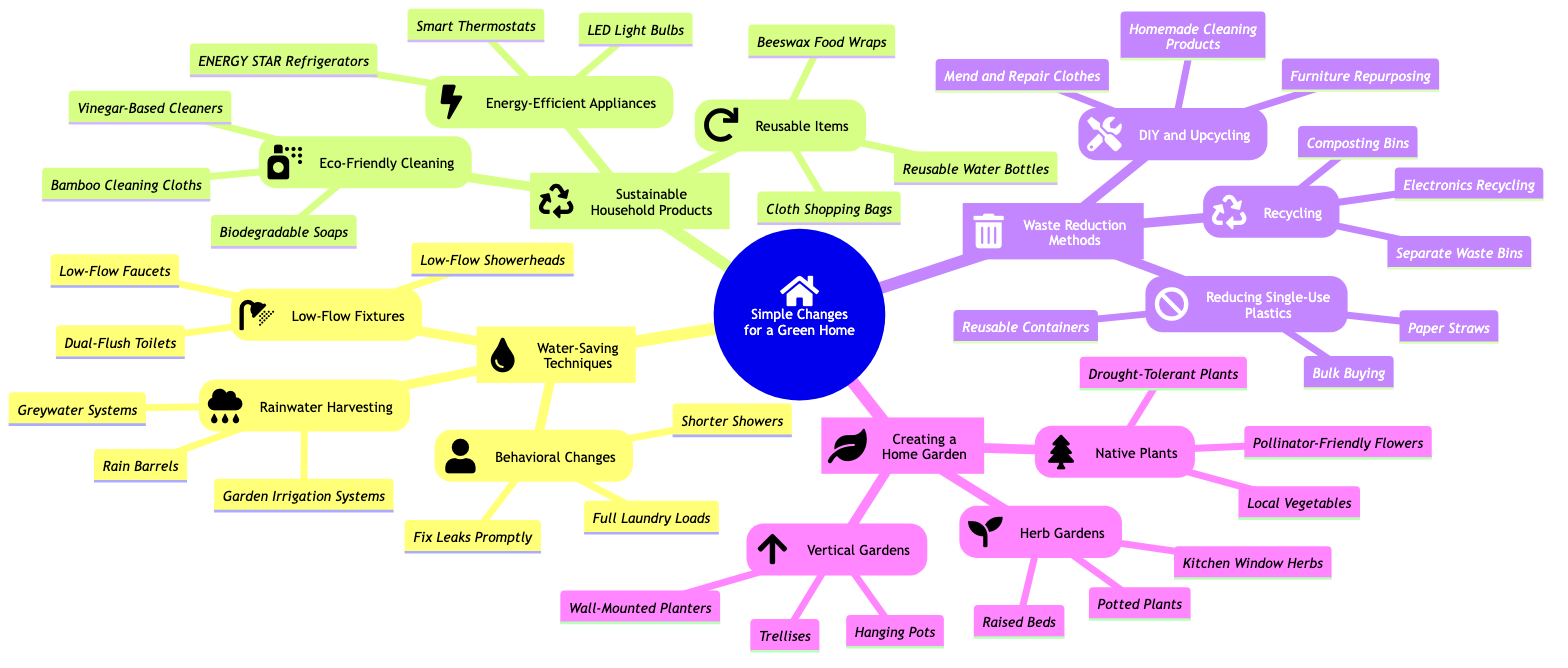What are the three categories under "Simple Changes for a Green Home"? The three categories are "Water-Saving Techniques," "Sustainable Household Products," and "Waste Reduction Methods." Each represents a different area of focus for achieving a greener home.
Answer: Water-Saving Techniques, Sustainable Household Products, Waste Reduction Methods How many types of water-saving techniques are listed? Under "Water-Saving Techniques," there are three types: "Low-Flow Fixtures," "Rainwater Harvesting," and "Behavioral Changes." This counts the main subcategories provided.
Answer: 3 What is one type of reusable item mentioned? The diagram lists "Cloth Shopping Bags" as an example of a reusable item. It's specifically mentioned under "Reusable Items" in the "Sustainable Household Products" category.
Answer: Cloth Shopping Bags Which category includes "Composting Bins"? "Composting Bins" is found in the "Recycling" section, which is part of the "Waste Reduction Methods." This categorization indicates its role in reducing waste.
Answer: Waste Reduction Methods How many items are listed under "Energy-Efficient Appliances"? There are three items listed: "ENERGY STAR Refrigerators," "LED Light Bulbs," and "Smart Thermostats." This shows the variety of energy-efficient appliances recommended.
Answer: 3 What type of garden includes "Kitchen Window Herbs"? "Kitchen Window Herbs" falls under the "Herb Gardens" section, which is part of the "Creating a Home Garden" category. This indicates a way to grow herbs in limited space.
Answer: Herb Gardens Which subcategory has the option "Dual-Flush Toilets"? "Dual-Flush Toilets" is listed under the "Low-Flow Fixtures" subcategory in the "Water-Saving Techniques" category. This highlights a specific method for saving water in toilets.
Answer: Low-Flow Fixtures What are two examples of behavior changes that help save water? "Shorter Showers" and "Fix Leaks Promptly" are both examples of behavioral changes that effectively contribute to water conservation. These are straightforward actions that individuals can take.
Answer: Shorter Showers, Fix Leaks Promptly 